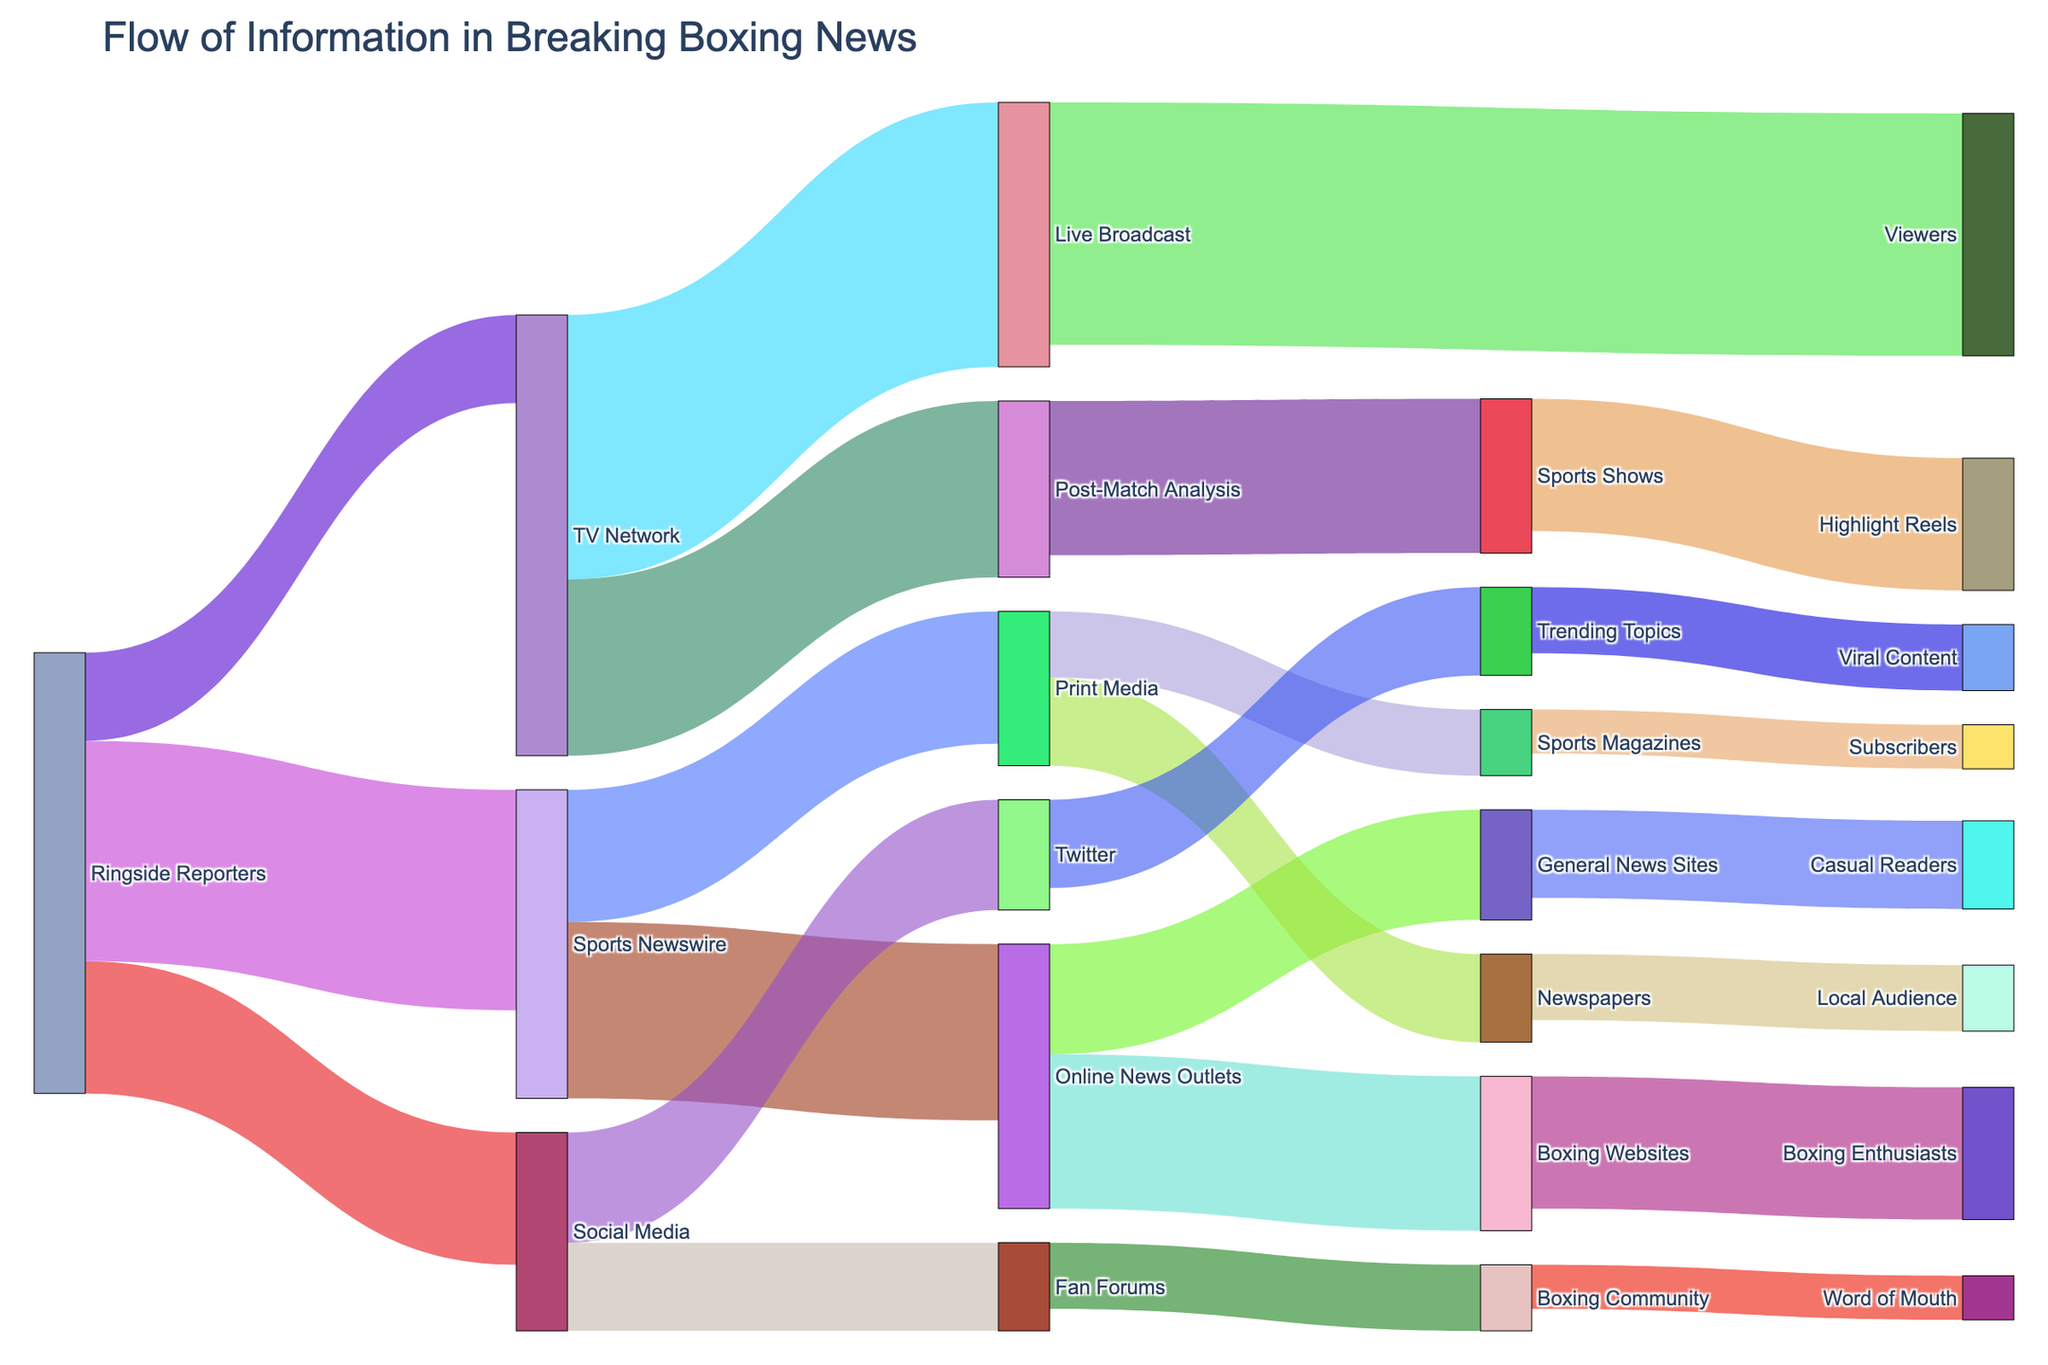Who is the main source of information in the breaking boxing news? By observing the thickness and frequency of the links originating, we can identify that Ringside Reporters have the highest number of connections with a total outward flow of 100 (50 to Sports Newswire, 30 to Social Media, and 20 to TV Network).
Answer: Ringside Reporters Which source directs the most information to TV Networks? Looking at the flows directed towards TV Network, Ringside Reporters are the sole contributors with a total flow of 20 units.
Answer: Ringside Reporters What is the total value of information flowing from TV Network? Summing up the values flowing out of TV Network (60 to Live Broadcast and 40 to Post-Match Analysis), we get a total flow of 100.
Answer: 100 How many sources does Print Media receive information from? By examining the links flowing into Print Media, two sources are identified: Sports Newswire (30) and Print Media (15).
Answer: 2 Which communication medium receives the highest information from Social Media? By comparing the values flowing from Social Media to other mediums, Twitter receives the highest with 25 units.
Answer: Twitter What is the combined flow of information towards Post-Match Analysis and Highlight Reels? The total flow towards Post-Match Analysis is 40 and towards Highlight Reels is 30. Combining these gives us 40 + 30 = 70.
Answer: 70 Who are the final recipients of information from Sports Newswire? The Sankey diagram shows that Sports Newswire directs information to Online News Outlets (40) and Print Media (30).
Answer: Online News Outlets and Print Media Which target receives the least amount of information from Print Media? Observing the values directed from Print Media, Sports Magazines receive the least with 15 units.
Answer: Sports Magazines Which node has the highest inflow of information? By comparing the inflows for all nodes, Post-Match Analysis receives the highest aggregated inflow of 40.
Answer: Post-Match Analysis What is the flow value from Fan Forums to the Boxing Community? The flow value from Fan Forums to the Boxing Community can be directly read off the Sankey diagram, which is 15.
Answer: 15 